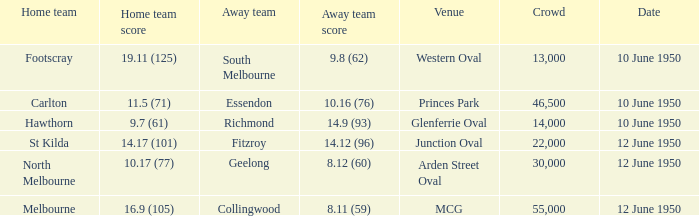What was the crowd when the VFL played MCG? 55000.0. 